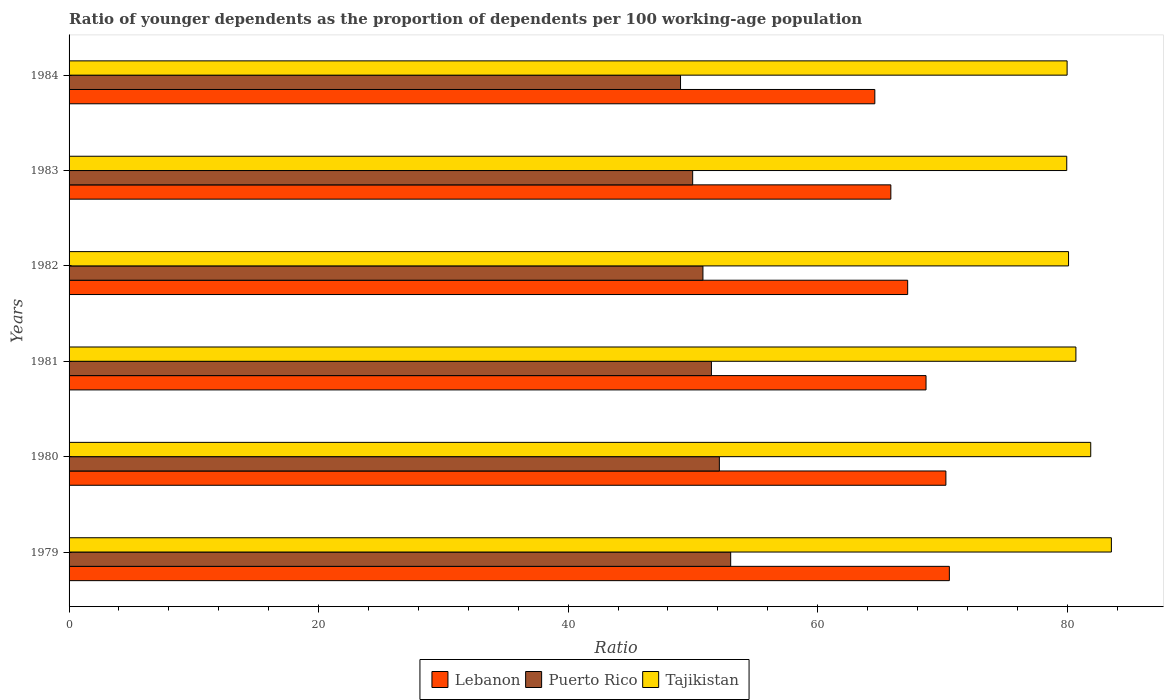How many groups of bars are there?
Offer a very short reply. 6. How many bars are there on the 1st tick from the top?
Provide a succinct answer. 3. What is the label of the 1st group of bars from the top?
Keep it short and to the point. 1984. In how many cases, is the number of bars for a given year not equal to the number of legend labels?
Keep it short and to the point. 0. What is the age dependency ratio(young) in Puerto Rico in 1981?
Ensure brevity in your answer.  51.49. Across all years, what is the maximum age dependency ratio(young) in Puerto Rico?
Offer a terse response. 53.03. Across all years, what is the minimum age dependency ratio(young) in Puerto Rico?
Your answer should be compact. 49.01. In which year was the age dependency ratio(young) in Lebanon maximum?
Offer a terse response. 1979. In which year was the age dependency ratio(young) in Puerto Rico minimum?
Your answer should be very brief. 1984. What is the total age dependency ratio(young) in Lebanon in the graph?
Make the answer very short. 407.18. What is the difference between the age dependency ratio(young) in Tajikistan in 1979 and that in 1983?
Give a very brief answer. 3.58. What is the difference between the age dependency ratio(young) in Lebanon in 1981 and the age dependency ratio(young) in Tajikistan in 1982?
Make the answer very short. -11.42. What is the average age dependency ratio(young) in Tajikistan per year?
Your answer should be compact. 81.03. In the year 1981, what is the difference between the age dependency ratio(young) in Tajikistan and age dependency ratio(young) in Lebanon?
Your answer should be very brief. 12.01. In how many years, is the age dependency ratio(young) in Lebanon greater than 48 ?
Offer a very short reply. 6. What is the ratio of the age dependency ratio(young) in Lebanon in 1982 to that in 1983?
Your answer should be compact. 1.02. What is the difference between the highest and the second highest age dependency ratio(young) in Tajikistan?
Your response must be concise. 1.65. What is the difference between the highest and the lowest age dependency ratio(young) in Puerto Rico?
Your response must be concise. 4.02. Is the sum of the age dependency ratio(young) in Puerto Rico in 1981 and 1982 greater than the maximum age dependency ratio(young) in Lebanon across all years?
Make the answer very short. Yes. What does the 2nd bar from the top in 1982 represents?
Your response must be concise. Puerto Rico. What does the 2nd bar from the bottom in 1981 represents?
Offer a very short reply. Puerto Rico. Are the values on the major ticks of X-axis written in scientific E-notation?
Your answer should be compact. No. Where does the legend appear in the graph?
Provide a succinct answer. Bottom center. How are the legend labels stacked?
Your answer should be very brief. Horizontal. What is the title of the graph?
Your answer should be compact. Ratio of younger dependents as the proportion of dependents per 100 working-age population. Does "Algeria" appear as one of the legend labels in the graph?
Keep it short and to the point. No. What is the label or title of the X-axis?
Your answer should be compact. Ratio. What is the Ratio of Lebanon in 1979?
Your answer should be very brief. 70.56. What is the Ratio in Puerto Rico in 1979?
Your answer should be very brief. 53.03. What is the Ratio in Tajikistan in 1979?
Ensure brevity in your answer.  83.54. What is the Ratio of Lebanon in 1980?
Your answer should be very brief. 70.28. What is the Ratio of Puerto Rico in 1980?
Offer a very short reply. 52.12. What is the Ratio of Tajikistan in 1980?
Your answer should be very brief. 81.89. What is the Ratio of Lebanon in 1981?
Keep it short and to the point. 68.69. What is the Ratio of Puerto Rico in 1981?
Offer a very short reply. 51.49. What is the Ratio of Tajikistan in 1981?
Ensure brevity in your answer.  80.7. What is the Ratio in Lebanon in 1982?
Keep it short and to the point. 67.21. What is the Ratio of Puerto Rico in 1982?
Your answer should be very brief. 50.8. What is the Ratio in Tajikistan in 1982?
Provide a succinct answer. 80.11. What is the Ratio of Lebanon in 1983?
Give a very brief answer. 65.87. What is the Ratio in Puerto Rico in 1983?
Provide a succinct answer. 49.98. What is the Ratio in Tajikistan in 1983?
Your answer should be very brief. 79.96. What is the Ratio of Lebanon in 1984?
Make the answer very short. 64.58. What is the Ratio in Puerto Rico in 1984?
Your answer should be compact. 49.01. What is the Ratio of Tajikistan in 1984?
Offer a terse response. 79.99. Across all years, what is the maximum Ratio in Lebanon?
Offer a very short reply. 70.56. Across all years, what is the maximum Ratio in Puerto Rico?
Make the answer very short. 53.03. Across all years, what is the maximum Ratio in Tajikistan?
Offer a terse response. 83.54. Across all years, what is the minimum Ratio in Lebanon?
Offer a very short reply. 64.58. Across all years, what is the minimum Ratio in Puerto Rico?
Your answer should be very brief. 49.01. Across all years, what is the minimum Ratio of Tajikistan?
Your answer should be very brief. 79.96. What is the total Ratio of Lebanon in the graph?
Offer a very short reply. 407.18. What is the total Ratio in Puerto Rico in the graph?
Your answer should be compact. 306.43. What is the total Ratio in Tajikistan in the graph?
Keep it short and to the point. 486.2. What is the difference between the Ratio of Lebanon in 1979 and that in 1980?
Your answer should be compact. 0.28. What is the difference between the Ratio of Puerto Rico in 1979 and that in 1980?
Make the answer very short. 0.91. What is the difference between the Ratio in Tajikistan in 1979 and that in 1980?
Offer a terse response. 1.65. What is the difference between the Ratio of Lebanon in 1979 and that in 1981?
Give a very brief answer. 1.87. What is the difference between the Ratio in Puerto Rico in 1979 and that in 1981?
Offer a terse response. 1.54. What is the difference between the Ratio of Tajikistan in 1979 and that in 1981?
Offer a very short reply. 2.84. What is the difference between the Ratio in Lebanon in 1979 and that in 1982?
Offer a very short reply. 3.34. What is the difference between the Ratio in Puerto Rico in 1979 and that in 1982?
Make the answer very short. 2.22. What is the difference between the Ratio in Tajikistan in 1979 and that in 1982?
Your response must be concise. 3.43. What is the difference between the Ratio in Lebanon in 1979 and that in 1983?
Provide a succinct answer. 4.69. What is the difference between the Ratio of Puerto Rico in 1979 and that in 1983?
Offer a terse response. 3.05. What is the difference between the Ratio in Tajikistan in 1979 and that in 1983?
Ensure brevity in your answer.  3.58. What is the difference between the Ratio of Lebanon in 1979 and that in 1984?
Give a very brief answer. 5.97. What is the difference between the Ratio of Puerto Rico in 1979 and that in 1984?
Your answer should be very brief. 4.02. What is the difference between the Ratio in Tajikistan in 1979 and that in 1984?
Offer a very short reply. 3.55. What is the difference between the Ratio of Lebanon in 1980 and that in 1981?
Your answer should be compact. 1.59. What is the difference between the Ratio of Puerto Rico in 1980 and that in 1981?
Give a very brief answer. 0.64. What is the difference between the Ratio of Tajikistan in 1980 and that in 1981?
Your answer should be compact. 1.19. What is the difference between the Ratio of Lebanon in 1980 and that in 1982?
Offer a terse response. 3.06. What is the difference between the Ratio of Puerto Rico in 1980 and that in 1982?
Ensure brevity in your answer.  1.32. What is the difference between the Ratio of Tajikistan in 1980 and that in 1982?
Offer a very short reply. 1.78. What is the difference between the Ratio in Lebanon in 1980 and that in 1983?
Give a very brief answer. 4.41. What is the difference between the Ratio of Puerto Rico in 1980 and that in 1983?
Your answer should be compact. 2.14. What is the difference between the Ratio in Tajikistan in 1980 and that in 1983?
Make the answer very short. 1.92. What is the difference between the Ratio of Lebanon in 1980 and that in 1984?
Your answer should be very brief. 5.7. What is the difference between the Ratio in Puerto Rico in 1980 and that in 1984?
Your answer should be compact. 3.11. What is the difference between the Ratio of Tajikistan in 1980 and that in 1984?
Give a very brief answer. 1.89. What is the difference between the Ratio of Lebanon in 1981 and that in 1982?
Offer a terse response. 1.47. What is the difference between the Ratio in Puerto Rico in 1981 and that in 1982?
Your response must be concise. 0.68. What is the difference between the Ratio in Tajikistan in 1981 and that in 1982?
Offer a very short reply. 0.59. What is the difference between the Ratio of Lebanon in 1981 and that in 1983?
Keep it short and to the point. 2.82. What is the difference between the Ratio in Puerto Rico in 1981 and that in 1983?
Provide a short and direct response. 1.5. What is the difference between the Ratio in Tajikistan in 1981 and that in 1983?
Offer a very short reply. 0.73. What is the difference between the Ratio in Lebanon in 1981 and that in 1984?
Provide a succinct answer. 4.1. What is the difference between the Ratio of Puerto Rico in 1981 and that in 1984?
Offer a very short reply. 2.48. What is the difference between the Ratio in Tajikistan in 1981 and that in 1984?
Keep it short and to the point. 0.7. What is the difference between the Ratio in Lebanon in 1982 and that in 1983?
Provide a short and direct response. 1.35. What is the difference between the Ratio in Puerto Rico in 1982 and that in 1983?
Keep it short and to the point. 0.82. What is the difference between the Ratio of Tajikistan in 1982 and that in 1983?
Ensure brevity in your answer.  0.14. What is the difference between the Ratio of Lebanon in 1982 and that in 1984?
Offer a very short reply. 2.63. What is the difference between the Ratio of Puerto Rico in 1982 and that in 1984?
Ensure brevity in your answer.  1.8. What is the difference between the Ratio in Tajikistan in 1982 and that in 1984?
Your answer should be compact. 0.12. What is the difference between the Ratio of Lebanon in 1983 and that in 1984?
Offer a terse response. 1.28. What is the difference between the Ratio in Puerto Rico in 1983 and that in 1984?
Your response must be concise. 0.97. What is the difference between the Ratio of Tajikistan in 1983 and that in 1984?
Give a very brief answer. -0.03. What is the difference between the Ratio in Lebanon in 1979 and the Ratio in Puerto Rico in 1980?
Make the answer very short. 18.43. What is the difference between the Ratio in Lebanon in 1979 and the Ratio in Tajikistan in 1980?
Provide a succinct answer. -11.33. What is the difference between the Ratio of Puerto Rico in 1979 and the Ratio of Tajikistan in 1980?
Give a very brief answer. -28.86. What is the difference between the Ratio in Lebanon in 1979 and the Ratio in Puerto Rico in 1981?
Provide a short and direct response. 19.07. What is the difference between the Ratio in Lebanon in 1979 and the Ratio in Tajikistan in 1981?
Give a very brief answer. -10.14. What is the difference between the Ratio in Puerto Rico in 1979 and the Ratio in Tajikistan in 1981?
Give a very brief answer. -27.67. What is the difference between the Ratio of Lebanon in 1979 and the Ratio of Puerto Rico in 1982?
Your answer should be compact. 19.75. What is the difference between the Ratio in Lebanon in 1979 and the Ratio in Tajikistan in 1982?
Ensure brevity in your answer.  -9.55. What is the difference between the Ratio of Puerto Rico in 1979 and the Ratio of Tajikistan in 1982?
Your response must be concise. -27.08. What is the difference between the Ratio in Lebanon in 1979 and the Ratio in Puerto Rico in 1983?
Your response must be concise. 20.57. What is the difference between the Ratio in Lebanon in 1979 and the Ratio in Tajikistan in 1983?
Offer a terse response. -9.41. What is the difference between the Ratio of Puerto Rico in 1979 and the Ratio of Tajikistan in 1983?
Provide a succinct answer. -26.94. What is the difference between the Ratio in Lebanon in 1979 and the Ratio in Puerto Rico in 1984?
Offer a very short reply. 21.55. What is the difference between the Ratio of Lebanon in 1979 and the Ratio of Tajikistan in 1984?
Give a very brief answer. -9.44. What is the difference between the Ratio in Puerto Rico in 1979 and the Ratio in Tajikistan in 1984?
Ensure brevity in your answer.  -26.96. What is the difference between the Ratio of Lebanon in 1980 and the Ratio of Puerto Rico in 1981?
Your answer should be very brief. 18.79. What is the difference between the Ratio in Lebanon in 1980 and the Ratio in Tajikistan in 1981?
Your response must be concise. -10.42. What is the difference between the Ratio in Puerto Rico in 1980 and the Ratio in Tajikistan in 1981?
Give a very brief answer. -28.58. What is the difference between the Ratio in Lebanon in 1980 and the Ratio in Puerto Rico in 1982?
Provide a succinct answer. 19.47. What is the difference between the Ratio in Lebanon in 1980 and the Ratio in Tajikistan in 1982?
Your answer should be compact. -9.83. What is the difference between the Ratio in Puerto Rico in 1980 and the Ratio in Tajikistan in 1982?
Offer a terse response. -27.99. What is the difference between the Ratio in Lebanon in 1980 and the Ratio in Puerto Rico in 1983?
Ensure brevity in your answer.  20.3. What is the difference between the Ratio of Lebanon in 1980 and the Ratio of Tajikistan in 1983?
Provide a succinct answer. -9.69. What is the difference between the Ratio in Puerto Rico in 1980 and the Ratio in Tajikistan in 1983?
Provide a succinct answer. -27.84. What is the difference between the Ratio in Lebanon in 1980 and the Ratio in Puerto Rico in 1984?
Provide a succinct answer. 21.27. What is the difference between the Ratio of Lebanon in 1980 and the Ratio of Tajikistan in 1984?
Provide a short and direct response. -9.72. What is the difference between the Ratio in Puerto Rico in 1980 and the Ratio in Tajikistan in 1984?
Keep it short and to the point. -27.87. What is the difference between the Ratio in Lebanon in 1981 and the Ratio in Puerto Rico in 1982?
Your response must be concise. 17.88. What is the difference between the Ratio in Lebanon in 1981 and the Ratio in Tajikistan in 1982?
Offer a terse response. -11.42. What is the difference between the Ratio of Puerto Rico in 1981 and the Ratio of Tajikistan in 1982?
Offer a terse response. -28.62. What is the difference between the Ratio in Lebanon in 1981 and the Ratio in Puerto Rico in 1983?
Offer a very short reply. 18.7. What is the difference between the Ratio in Lebanon in 1981 and the Ratio in Tajikistan in 1983?
Offer a terse response. -11.28. What is the difference between the Ratio in Puerto Rico in 1981 and the Ratio in Tajikistan in 1983?
Provide a succinct answer. -28.48. What is the difference between the Ratio in Lebanon in 1981 and the Ratio in Puerto Rico in 1984?
Your response must be concise. 19.68. What is the difference between the Ratio in Lebanon in 1981 and the Ratio in Tajikistan in 1984?
Make the answer very short. -11.31. What is the difference between the Ratio of Puerto Rico in 1981 and the Ratio of Tajikistan in 1984?
Provide a succinct answer. -28.51. What is the difference between the Ratio of Lebanon in 1982 and the Ratio of Puerto Rico in 1983?
Give a very brief answer. 17.23. What is the difference between the Ratio in Lebanon in 1982 and the Ratio in Tajikistan in 1983?
Give a very brief answer. -12.75. What is the difference between the Ratio of Puerto Rico in 1982 and the Ratio of Tajikistan in 1983?
Provide a succinct answer. -29.16. What is the difference between the Ratio of Lebanon in 1982 and the Ratio of Puerto Rico in 1984?
Offer a very short reply. 18.21. What is the difference between the Ratio of Lebanon in 1982 and the Ratio of Tajikistan in 1984?
Give a very brief answer. -12.78. What is the difference between the Ratio of Puerto Rico in 1982 and the Ratio of Tajikistan in 1984?
Give a very brief answer. -29.19. What is the difference between the Ratio in Lebanon in 1983 and the Ratio in Puerto Rico in 1984?
Offer a terse response. 16.86. What is the difference between the Ratio in Lebanon in 1983 and the Ratio in Tajikistan in 1984?
Ensure brevity in your answer.  -14.13. What is the difference between the Ratio of Puerto Rico in 1983 and the Ratio of Tajikistan in 1984?
Provide a succinct answer. -30.01. What is the average Ratio in Lebanon per year?
Give a very brief answer. 67.86. What is the average Ratio of Puerto Rico per year?
Offer a very short reply. 51.07. What is the average Ratio of Tajikistan per year?
Offer a terse response. 81.03. In the year 1979, what is the difference between the Ratio of Lebanon and Ratio of Puerto Rico?
Provide a succinct answer. 17.53. In the year 1979, what is the difference between the Ratio in Lebanon and Ratio in Tajikistan?
Ensure brevity in your answer.  -12.99. In the year 1979, what is the difference between the Ratio of Puerto Rico and Ratio of Tajikistan?
Your answer should be very brief. -30.51. In the year 1980, what is the difference between the Ratio of Lebanon and Ratio of Puerto Rico?
Your answer should be compact. 18.16. In the year 1980, what is the difference between the Ratio in Lebanon and Ratio in Tajikistan?
Provide a short and direct response. -11.61. In the year 1980, what is the difference between the Ratio in Puerto Rico and Ratio in Tajikistan?
Make the answer very short. -29.77. In the year 1981, what is the difference between the Ratio in Lebanon and Ratio in Puerto Rico?
Ensure brevity in your answer.  17.2. In the year 1981, what is the difference between the Ratio in Lebanon and Ratio in Tajikistan?
Provide a succinct answer. -12.01. In the year 1981, what is the difference between the Ratio of Puerto Rico and Ratio of Tajikistan?
Ensure brevity in your answer.  -29.21. In the year 1982, what is the difference between the Ratio in Lebanon and Ratio in Puerto Rico?
Offer a very short reply. 16.41. In the year 1982, what is the difference between the Ratio of Lebanon and Ratio of Tajikistan?
Keep it short and to the point. -12.89. In the year 1982, what is the difference between the Ratio of Puerto Rico and Ratio of Tajikistan?
Offer a very short reply. -29.3. In the year 1983, what is the difference between the Ratio in Lebanon and Ratio in Puerto Rico?
Your answer should be compact. 15.88. In the year 1983, what is the difference between the Ratio in Lebanon and Ratio in Tajikistan?
Make the answer very short. -14.1. In the year 1983, what is the difference between the Ratio in Puerto Rico and Ratio in Tajikistan?
Provide a short and direct response. -29.98. In the year 1984, what is the difference between the Ratio in Lebanon and Ratio in Puerto Rico?
Offer a terse response. 15.57. In the year 1984, what is the difference between the Ratio in Lebanon and Ratio in Tajikistan?
Offer a terse response. -15.41. In the year 1984, what is the difference between the Ratio in Puerto Rico and Ratio in Tajikistan?
Offer a terse response. -30.99. What is the ratio of the Ratio in Puerto Rico in 1979 to that in 1980?
Offer a very short reply. 1.02. What is the ratio of the Ratio in Tajikistan in 1979 to that in 1980?
Give a very brief answer. 1.02. What is the ratio of the Ratio in Lebanon in 1979 to that in 1981?
Your answer should be compact. 1.03. What is the ratio of the Ratio in Tajikistan in 1979 to that in 1981?
Your response must be concise. 1.04. What is the ratio of the Ratio in Lebanon in 1979 to that in 1982?
Provide a short and direct response. 1.05. What is the ratio of the Ratio in Puerto Rico in 1979 to that in 1982?
Your answer should be very brief. 1.04. What is the ratio of the Ratio of Tajikistan in 1979 to that in 1982?
Your answer should be very brief. 1.04. What is the ratio of the Ratio of Lebanon in 1979 to that in 1983?
Ensure brevity in your answer.  1.07. What is the ratio of the Ratio of Puerto Rico in 1979 to that in 1983?
Give a very brief answer. 1.06. What is the ratio of the Ratio in Tajikistan in 1979 to that in 1983?
Ensure brevity in your answer.  1.04. What is the ratio of the Ratio of Lebanon in 1979 to that in 1984?
Provide a succinct answer. 1.09. What is the ratio of the Ratio in Puerto Rico in 1979 to that in 1984?
Keep it short and to the point. 1.08. What is the ratio of the Ratio in Tajikistan in 1979 to that in 1984?
Ensure brevity in your answer.  1.04. What is the ratio of the Ratio of Lebanon in 1980 to that in 1981?
Ensure brevity in your answer.  1.02. What is the ratio of the Ratio of Puerto Rico in 1980 to that in 1981?
Give a very brief answer. 1.01. What is the ratio of the Ratio in Tajikistan in 1980 to that in 1981?
Give a very brief answer. 1.01. What is the ratio of the Ratio in Lebanon in 1980 to that in 1982?
Provide a short and direct response. 1.05. What is the ratio of the Ratio in Puerto Rico in 1980 to that in 1982?
Your answer should be very brief. 1.03. What is the ratio of the Ratio in Tajikistan in 1980 to that in 1982?
Offer a terse response. 1.02. What is the ratio of the Ratio in Lebanon in 1980 to that in 1983?
Give a very brief answer. 1.07. What is the ratio of the Ratio in Puerto Rico in 1980 to that in 1983?
Keep it short and to the point. 1.04. What is the ratio of the Ratio of Tajikistan in 1980 to that in 1983?
Provide a succinct answer. 1.02. What is the ratio of the Ratio in Lebanon in 1980 to that in 1984?
Provide a succinct answer. 1.09. What is the ratio of the Ratio in Puerto Rico in 1980 to that in 1984?
Your response must be concise. 1.06. What is the ratio of the Ratio in Tajikistan in 1980 to that in 1984?
Keep it short and to the point. 1.02. What is the ratio of the Ratio of Lebanon in 1981 to that in 1982?
Provide a short and direct response. 1.02. What is the ratio of the Ratio of Puerto Rico in 1981 to that in 1982?
Your answer should be compact. 1.01. What is the ratio of the Ratio in Tajikistan in 1981 to that in 1982?
Keep it short and to the point. 1.01. What is the ratio of the Ratio in Lebanon in 1981 to that in 1983?
Provide a short and direct response. 1.04. What is the ratio of the Ratio in Puerto Rico in 1981 to that in 1983?
Your answer should be very brief. 1.03. What is the ratio of the Ratio of Tajikistan in 1981 to that in 1983?
Offer a terse response. 1.01. What is the ratio of the Ratio of Lebanon in 1981 to that in 1984?
Provide a short and direct response. 1.06. What is the ratio of the Ratio in Puerto Rico in 1981 to that in 1984?
Offer a very short reply. 1.05. What is the ratio of the Ratio of Tajikistan in 1981 to that in 1984?
Give a very brief answer. 1.01. What is the ratio of the Ratio of Lebanon in 1982 to that in 1983?
Ensure brevity in your answer.  1.02. What is the ratio of the Ratio in Puerto Rico in 1982 to that in 1983?
Make the answer very short. 1.02. What is the ratio of the Ratio in Lebanon in 1982 to that in 1984?
Offer a terse response. 1.04. What is the ratio of the Ratio of Puerto Rico in 1982 to that in 1984?
Ensure brevity in your answer.  1.04. What is the ratio of the Ratio in Lebanon in 1983 to that in 1984?
Your response must be concise. 1.02. What is the ratio of the Ratio of Puerto Rico in 1983 to that in 1984?
Offer a terse response. 1.02. What is the difference between the highest and the second highest Ratio in Lebanon?
Provide a succinct answer. 0.28. What is the difference between the highest and the second highest Ratio of Puerto Rico?
Your response must be concise. 0.91. What is the difference between the highest and the second highest Ratio in Tajikistan?
Your answer should be very brief. 1.65. What is the difference between the highest and the lowest Ratio in Lebanon?
Offer a terse response. 5.97. What is the difference between the highest and the lowest Ratio of Puerto Rico?
Your answer should be very brief. 4.02. What is the difference between the highest and the lowest Ratio of Tajikistan?
Provide a short and direct response. 3.58. 